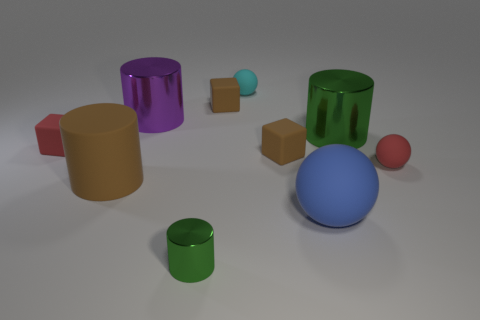Subtract 1 cylinders. How many cylinders are left? 3 Subtract all spheres. How many objects are left? 7 Add 8 large rubber things. How many large rubber things exist? 10 Subtract 1 cyan balls. How many objects are left? 9 Subtract all spheres. Subtract all big brown cylinders. How many objects are left? 6 Add 7 red cubes. How many red cubes are left? 8 